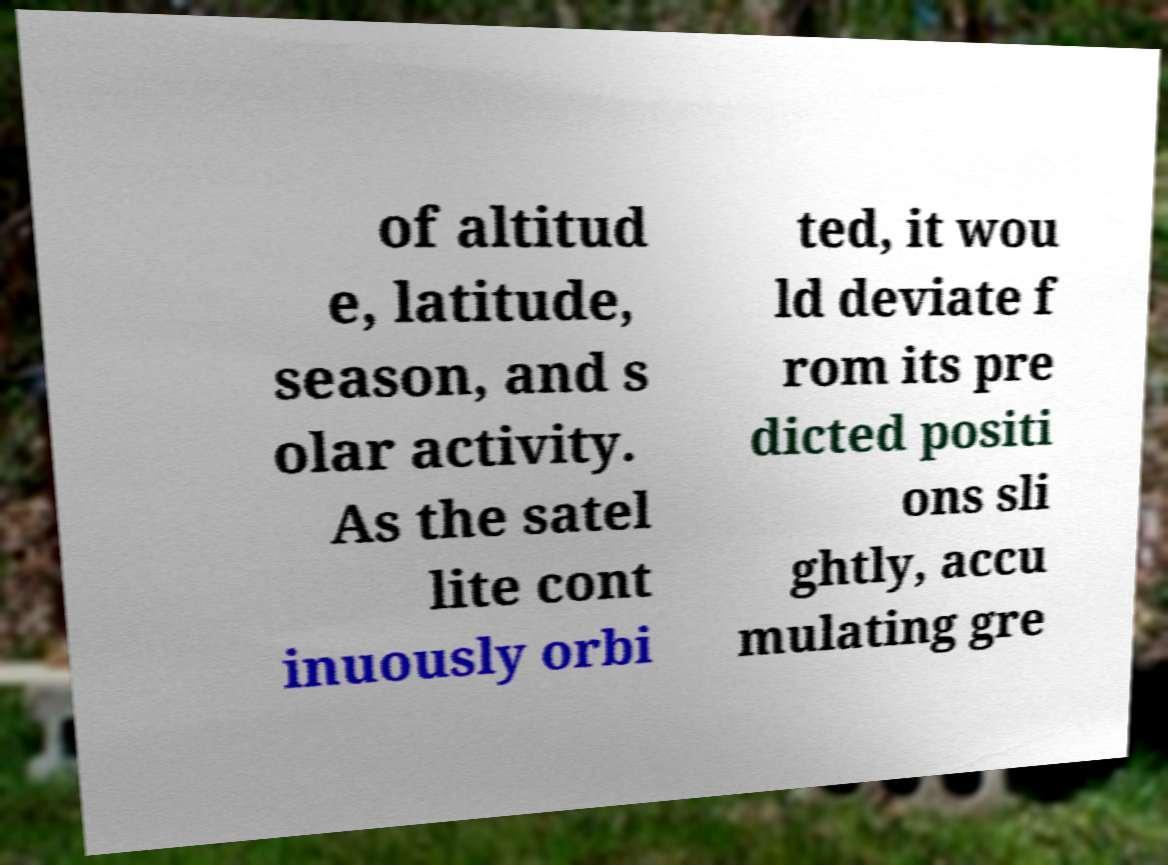Can you accurately transcribe the text from the provided image for me? of altitud e, latitude, season, and s olar activity. As the satel lite cont inuously orbi ted, it wou ld deviate f rom its pre dicted positi ons sli ghtly, accu mulating gre 